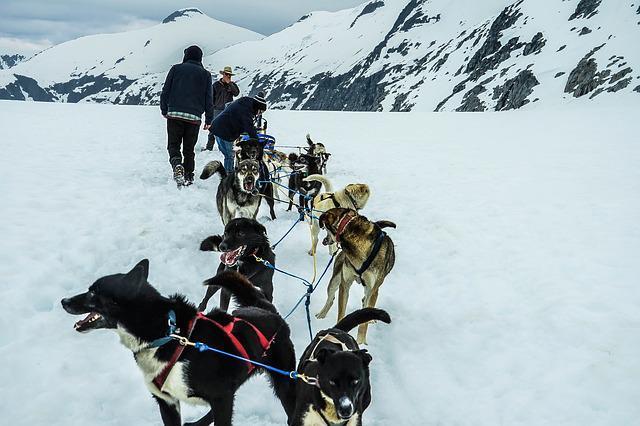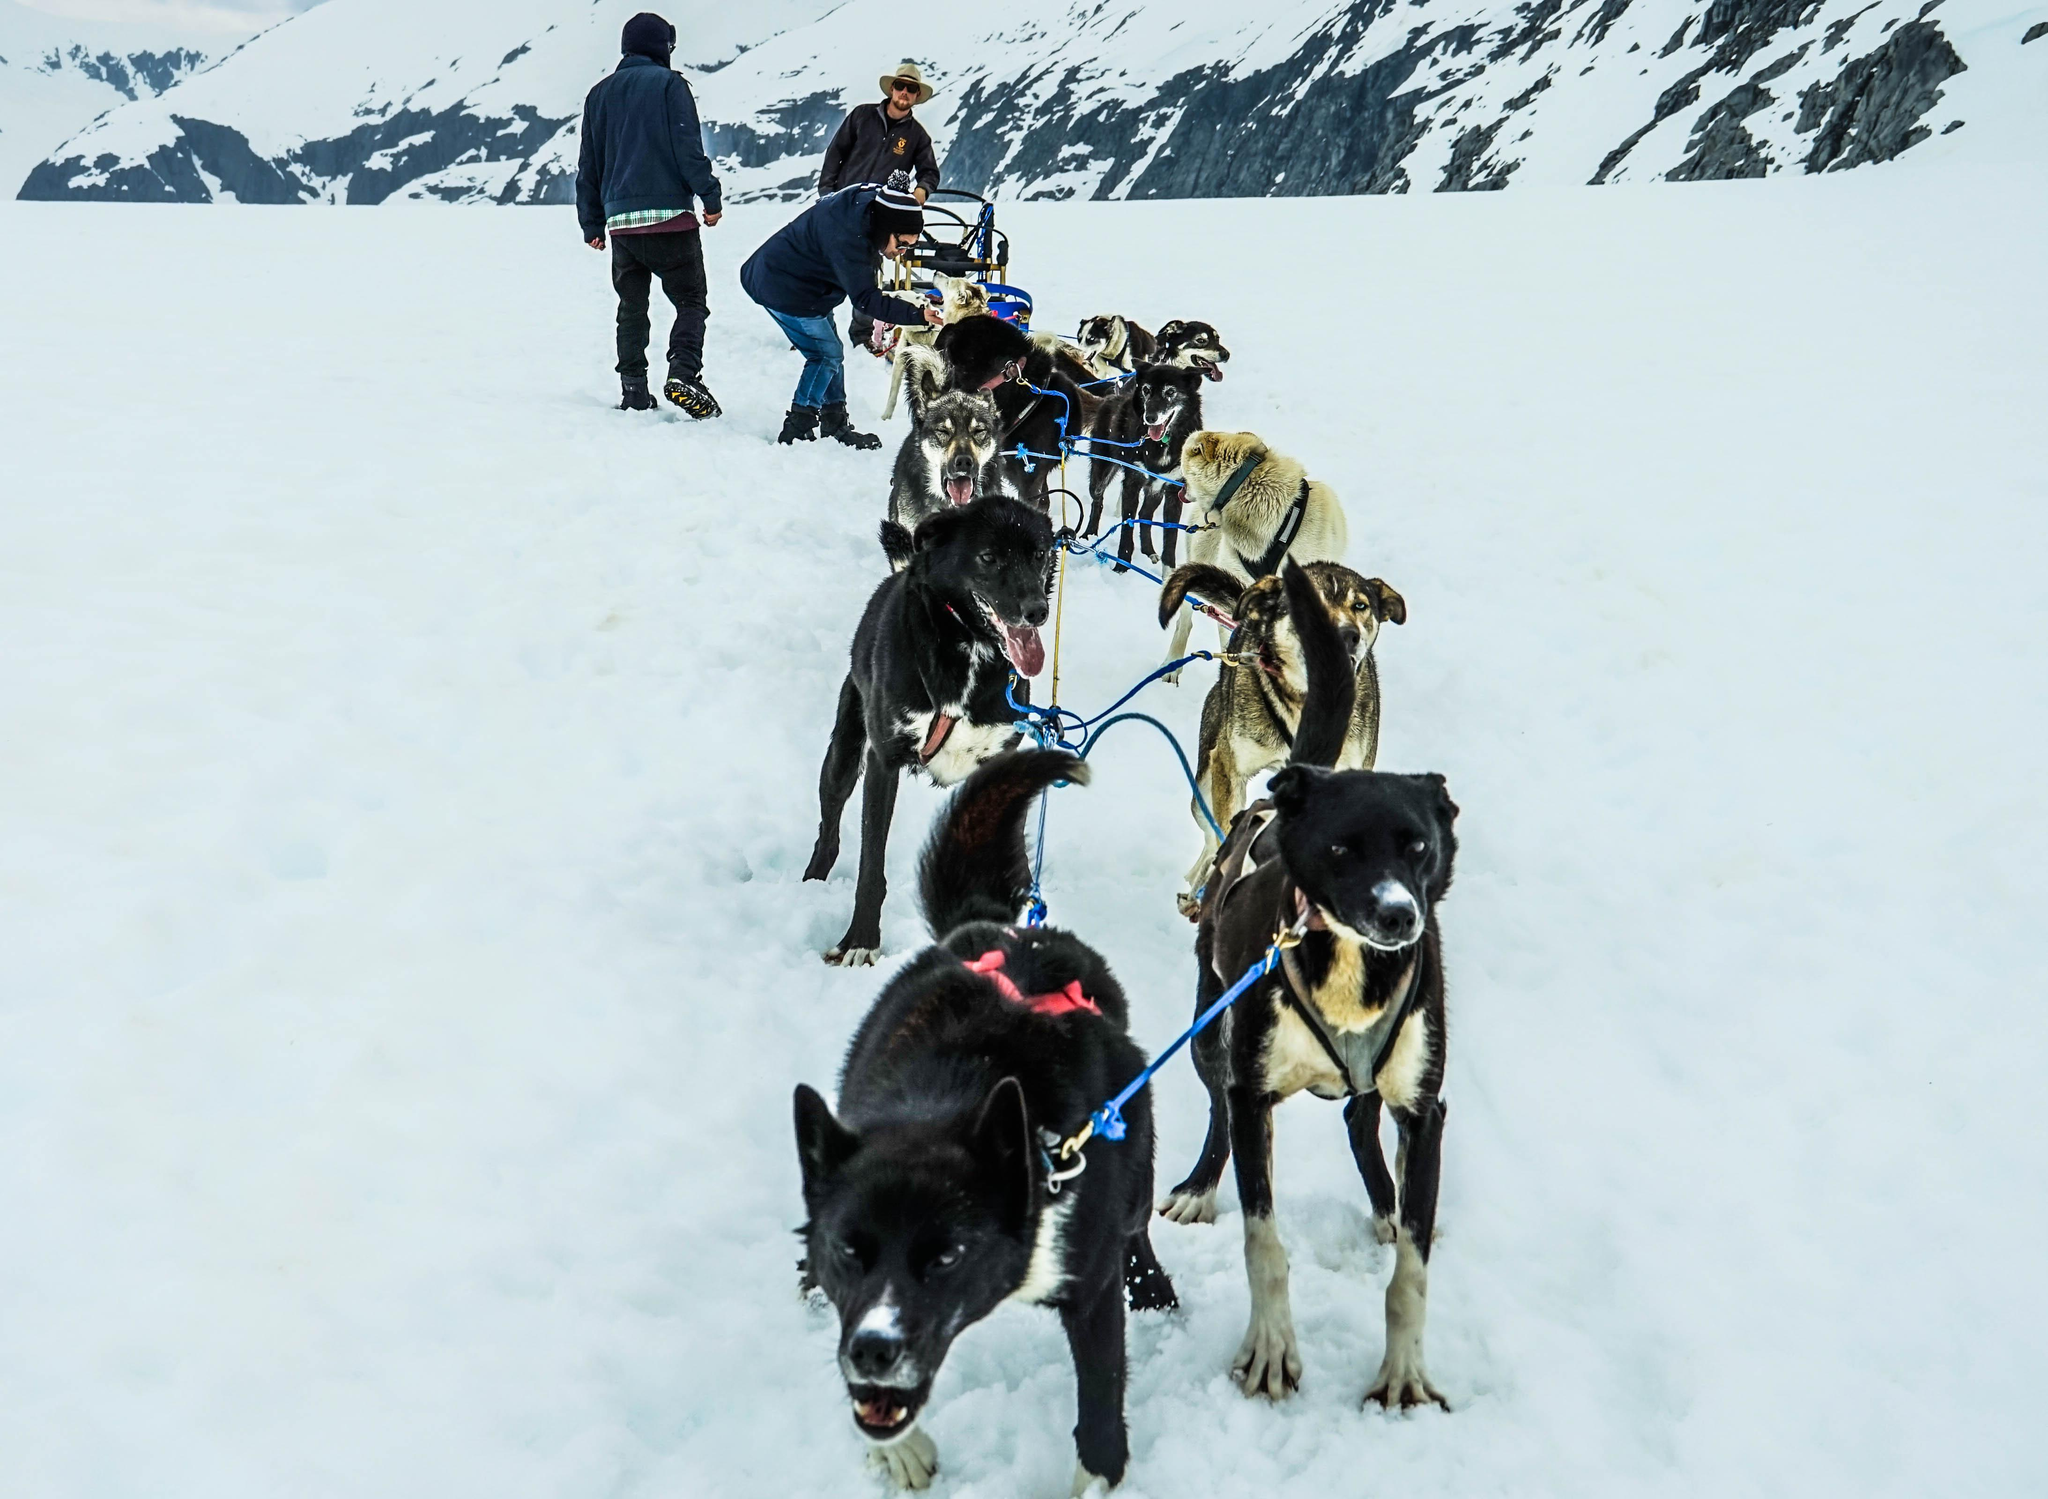The first image is the image on the left, the second image is the image on the right. For the images displayed, is the sentence "One image shows people riding the dogsled, the other does not." factually correct? Answer yes or no. No. The first image is the image on the left, the second image is the image on the right. Examine the images to the left and right. Is the description "At least one of the images shows a predominately black dog with white accents wearing a bright red harness on its body." accurate? Answer yes or no. Yes. 